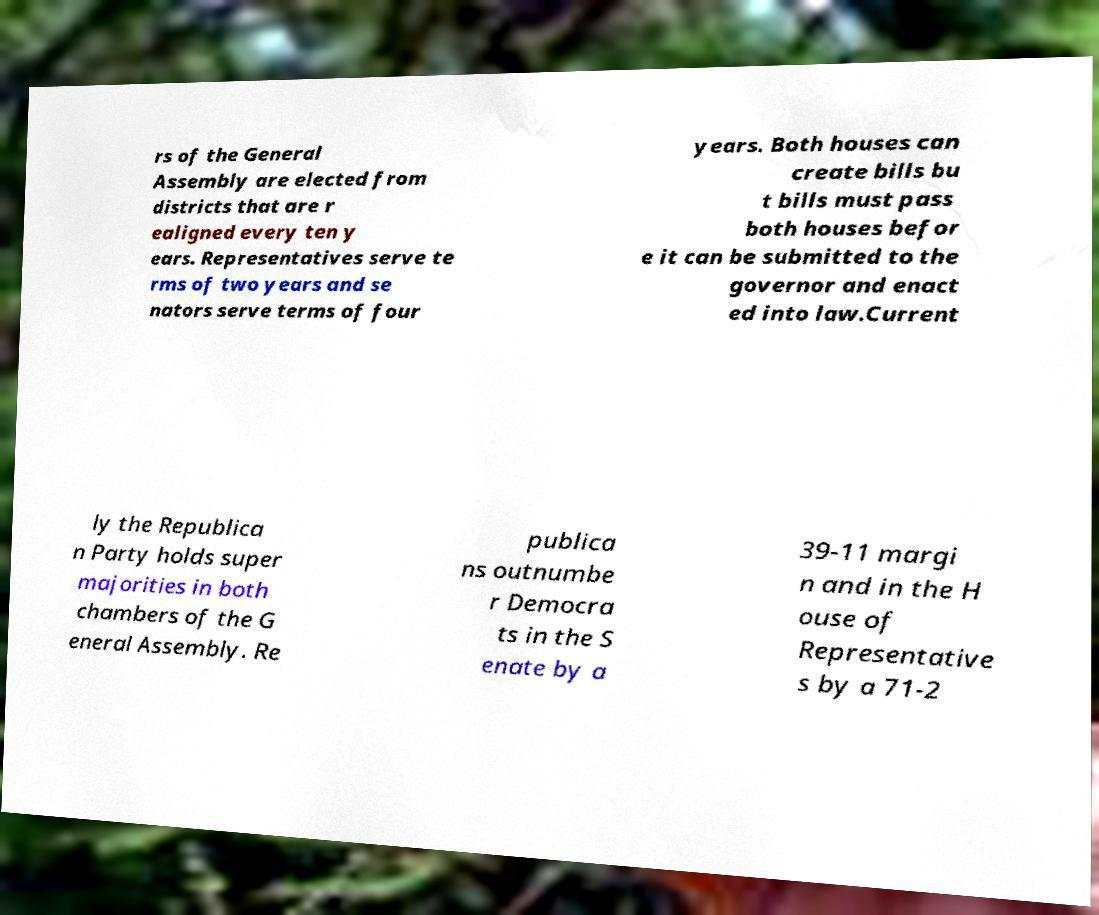Could you assist in decoding the text presented in this image and type it out clearly? rs of the General Assembly are elected from districts that are r ealigned every ten y ears. Representatives serve te rms of two years and se nators serve terms of four years. Both houses can create bills bu t bills must pass both houses befor e it can be submitted to the governor and enact ed into law.Current ly the Republica n Party holds super majorities in both chambers of the G eneral Assembly. Re publica ns outnumbe r Democra ts in the S enate by a 39-11 margi n and in the H ouse of Representative s by a 71-2 